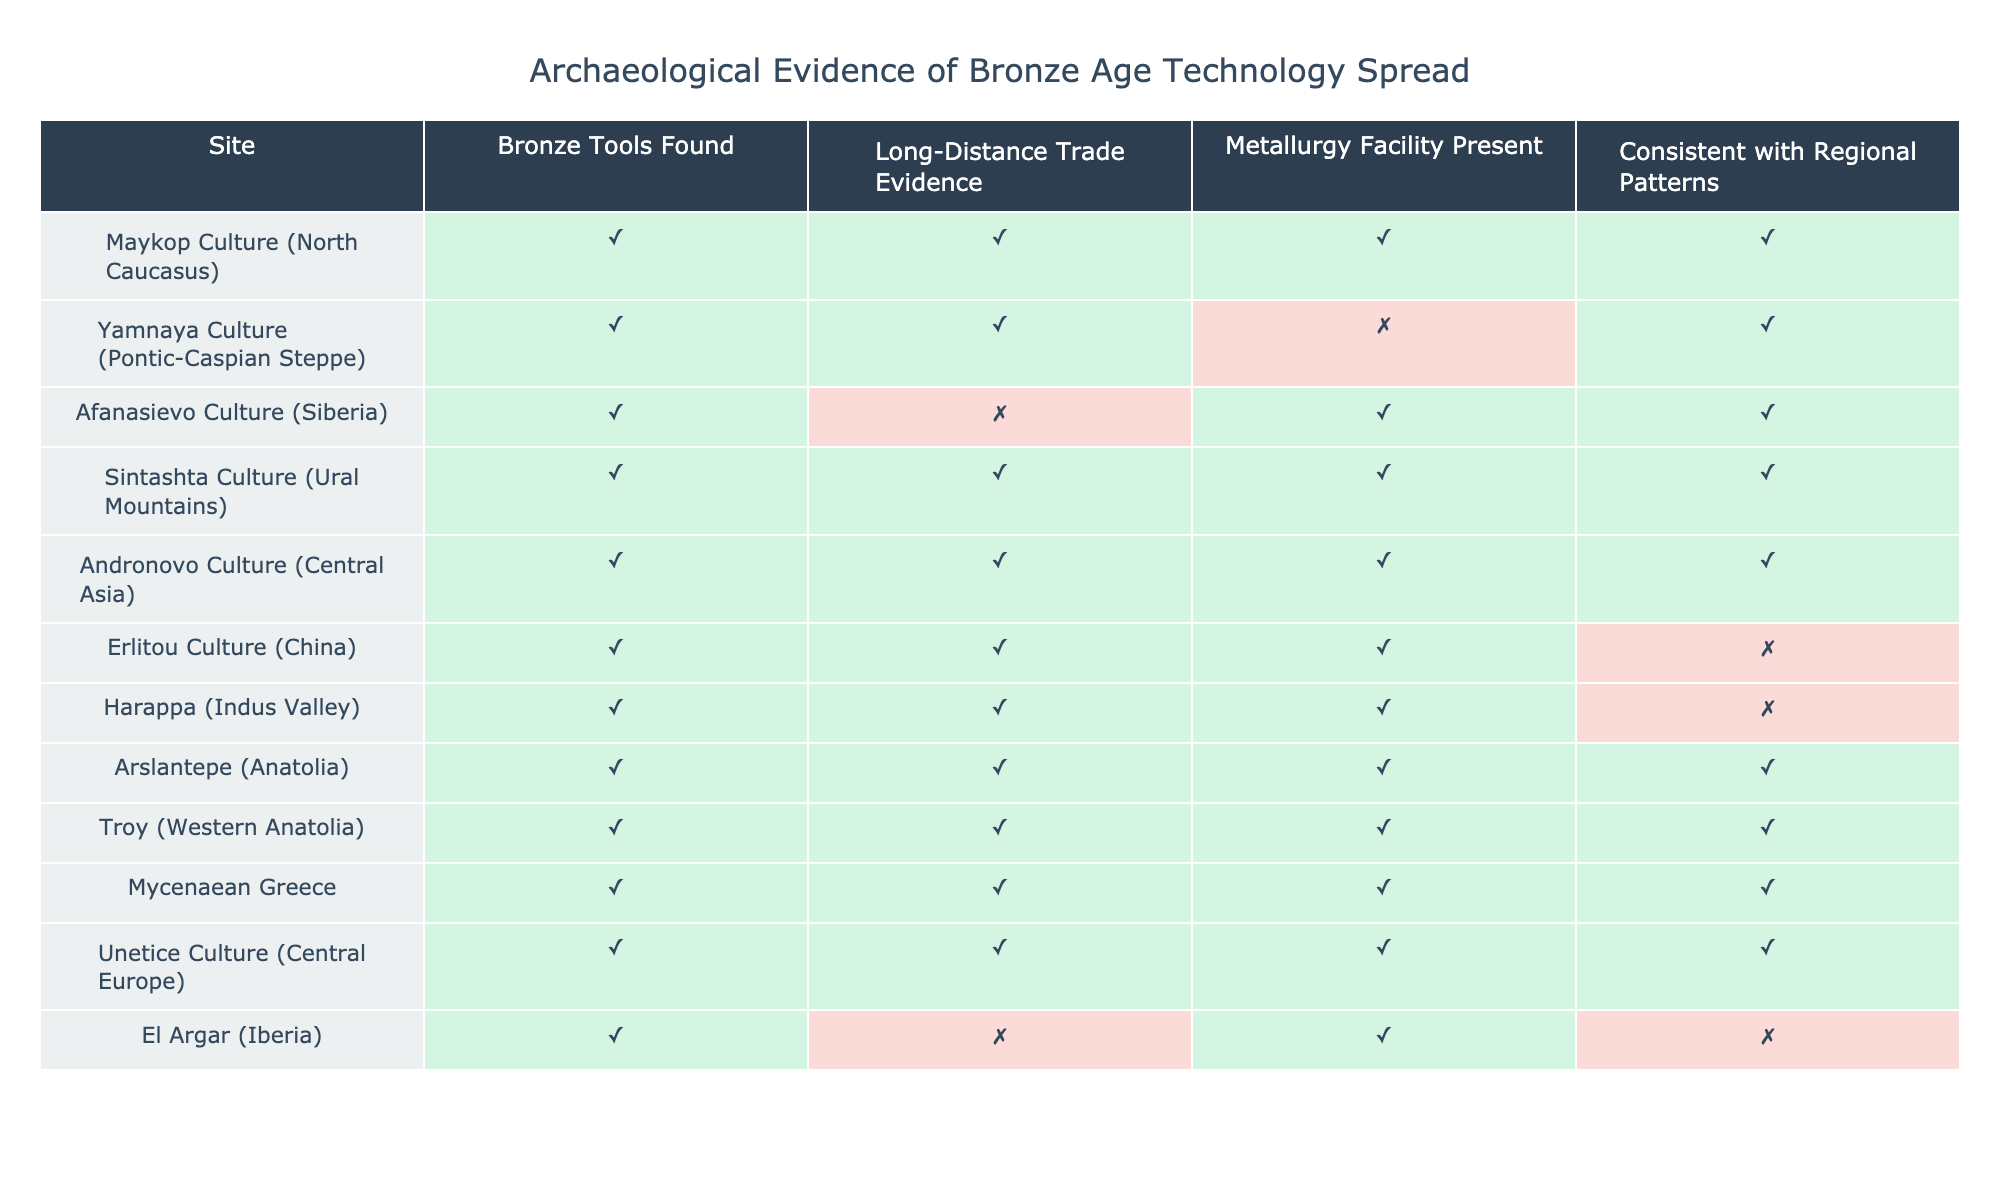What is the total number of sites where Bronze tools were found? In the table, every site has "TRUE" under the "Bronze Tools Found" column, indicating that tools were found at all sites. Since there are 10 sites listed, the total number is 10.
Answer: 10 How many sites exhibit evidence of long-distance trade? By looking at the "Long-Distance Trade Evidence" column, we see that there are 8 sites marked "TRUE." Therefore, the total is 8.
Answer: 8 Do the Erlitou Culture and Harappa both exhibit evidence of metallurgy facilities? In the "Metallurgy Facility Present" column, Erlitou Culture is marked "TRUE" while Harappa is also marked "TRUE." Therefore, yes, both sites exhibit evidence of metallurgy facilities.
Answer: Yes Which culture is the only one with Bronze tools and a metallurgy facility that does not fit regional patterns? The Erlitou Culture has "TRUE" under "Bronze Tools Found" and "Metallurgy Facility Present," but "FALSE" under "Consistent with Regional Patterns." Hence, it is the only culture fitting these criteria.
Answer: Erlitou Culture How many sites have both evidence of long-distance trade and metallurgy facilities? The sites that have both "TRUE" for "Long-Distance Trade Evidence" and "Metallurgy Facility Present" are Maykop, Sintashta, Andronovo, Arslantepe, Troy, Mycenaean Greece, and Unetice Culture. Counting these gives us a total of 7 sites.
Answer: 7 Is there any culture among those listed that has developed metallurgy facilities but lacks evidence of long-distance trade? Examining the "Long-Distance Trade Evidence" column alongside "Metallurgy Facility Present," we find that the Afanasievo Culture is the only one with "TRUE" for metallurgy but "FALSE" for long-distance trade, therefore yes, there is such a culture.
Answer: Yes How do the number of sites with evidence of long-distance trade compare to those without? There are 8 sites with "TRUE" under "Long-Distance Trade Evidence" and 2 with "FALSE." Thus, the comparison results in 8 sites with trade evidence and 2 without.
Answer: 8:2 Which two cultures found Bronze tools but do not show evidence of long-distance trade? The El Argar and Afanasievo Cultures both have "TRUE" for "Bronze Tools Found" and "FALSE" under "Long-Distance Trade Evidence." Thus, these two cultures are the answer.
Answer: El Argar, Afanasievo What percentage of sites have consistent regional patterns identified? In the "Consistent with Regional Patterns" column, there are 6 sites marked "TRUE" out of a total of 10. To find the percentage: (6/10) * 100 = 60%.
Answer: 60% 